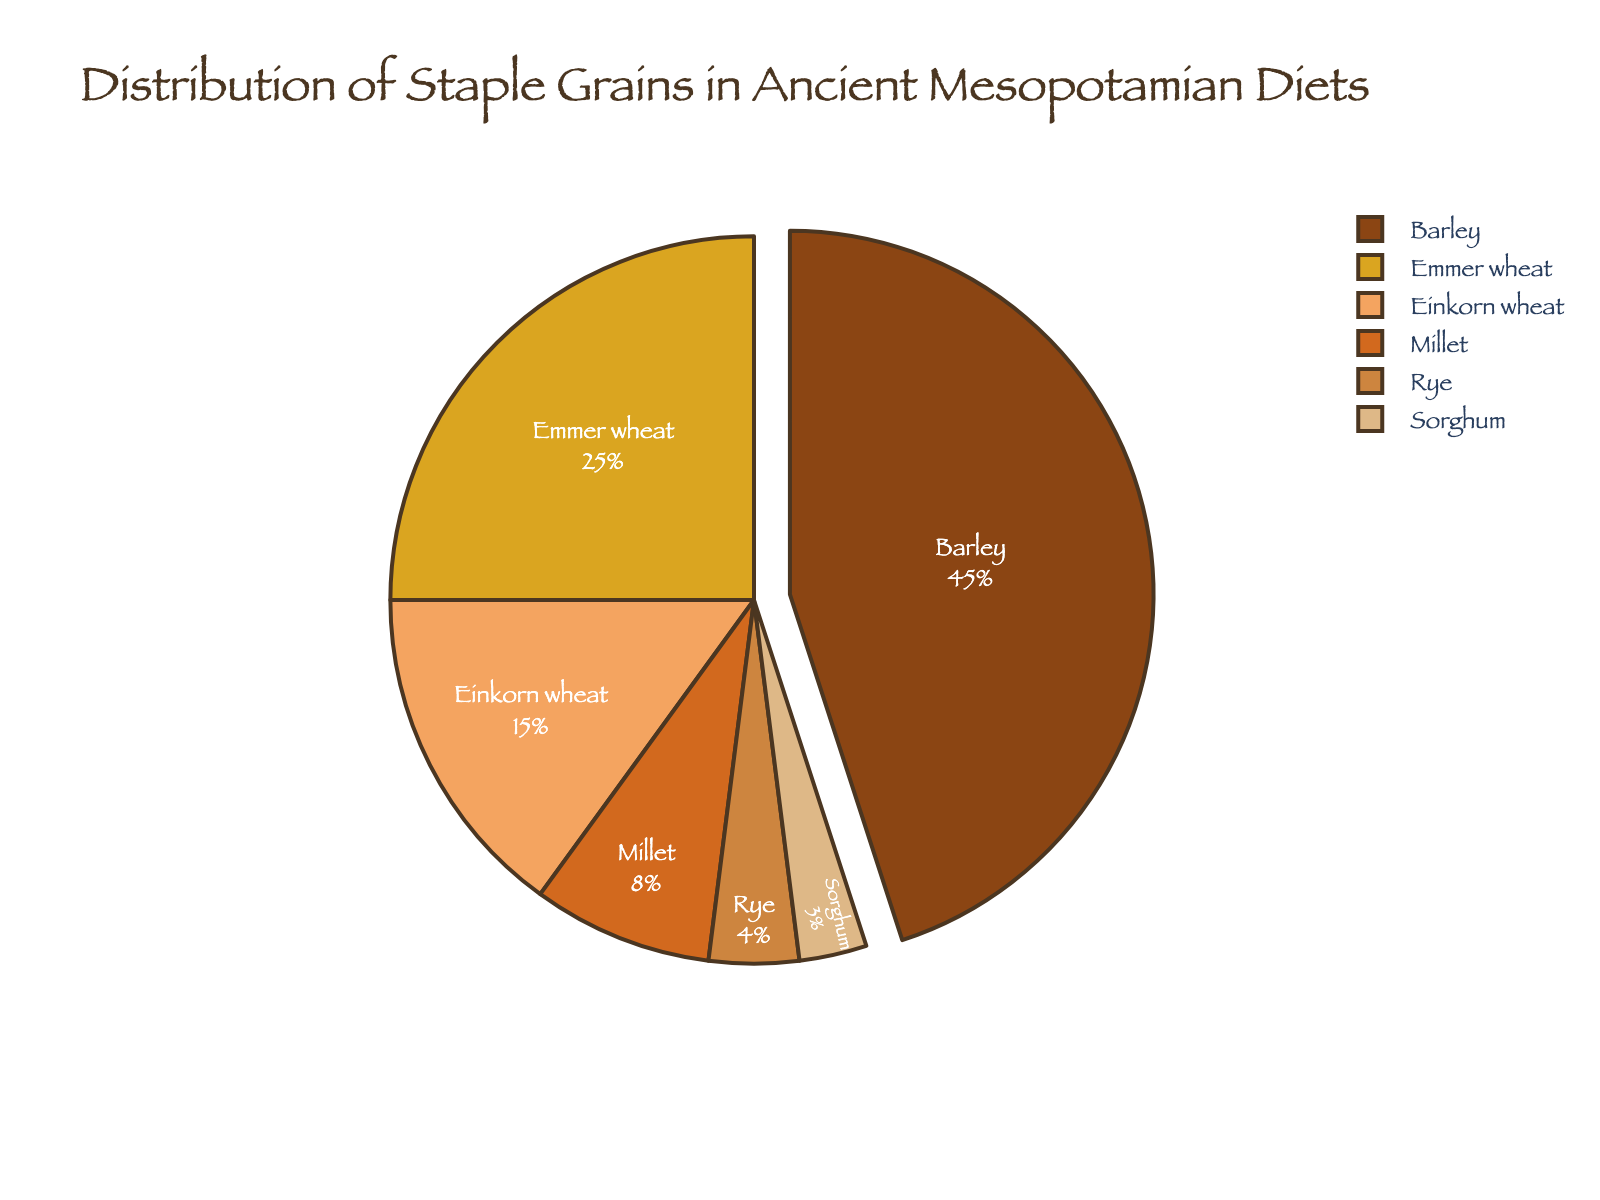What percentage of the ancient Mesopotamian diet was made up of barley and emmer wheat combined? Add the percentage of barley (45%) and emmer wheat (25%) together: 45 + 25 = 70.
Answer: 70% Which grain accounts for the smallest portion of the diet? Look at the chart and identify the grain with the smallest percentage. Sorghum has the smallest portion at 3%.
Answer: Sorghum How does the percentage of barley compare to the combined percentage of millet and rye? Add the percentage of millet (8%) and rye (4%) together: 8 + 4 = 12. Barley (45%) is greater than the combined percentage of millet and rye (12%).
Answer: Barley is greater What percentage does einkorn wheat contribute to the diet? Look at the pie chart and find einkorn wheat, which contributes 15% to the diet.
Answer: 15% What is the visual representation of the grain that is the second most prevalent in the diet? Identify the second largest segment in the pie chart. Emmer wheat, which makes up 25%, is the second most prevalent.
Answer: Emmer wheat If the segments for millet and sorghum were combined, what would their total percentage be? Add the percentage of millet (8%) and sorghum (3%) together: 8 + 3 = 11.
Answer: 11% Between rye and sorghum, which grain has a higher percentage and by how much? Compare the percentages: rye (4%) and sorghum (3%). Rye is 1% higher than sorghum.
Answer: Rye by 1% Which grains, when considered together, make up more than half of the diet? Add the percentages and find the combination that exceeds 50%. Barley (45%) and emmer wheat (25%) together make 70%, which is more than half.
Answer: Barley and emmer wheat What is the approximate percentage difference between the most prevalent grain and the least prevalent grain? Subtract the percentage of sorghum (3%) from the percentage of barley (45%): 45 - 3 = 42.
Answer: 42 